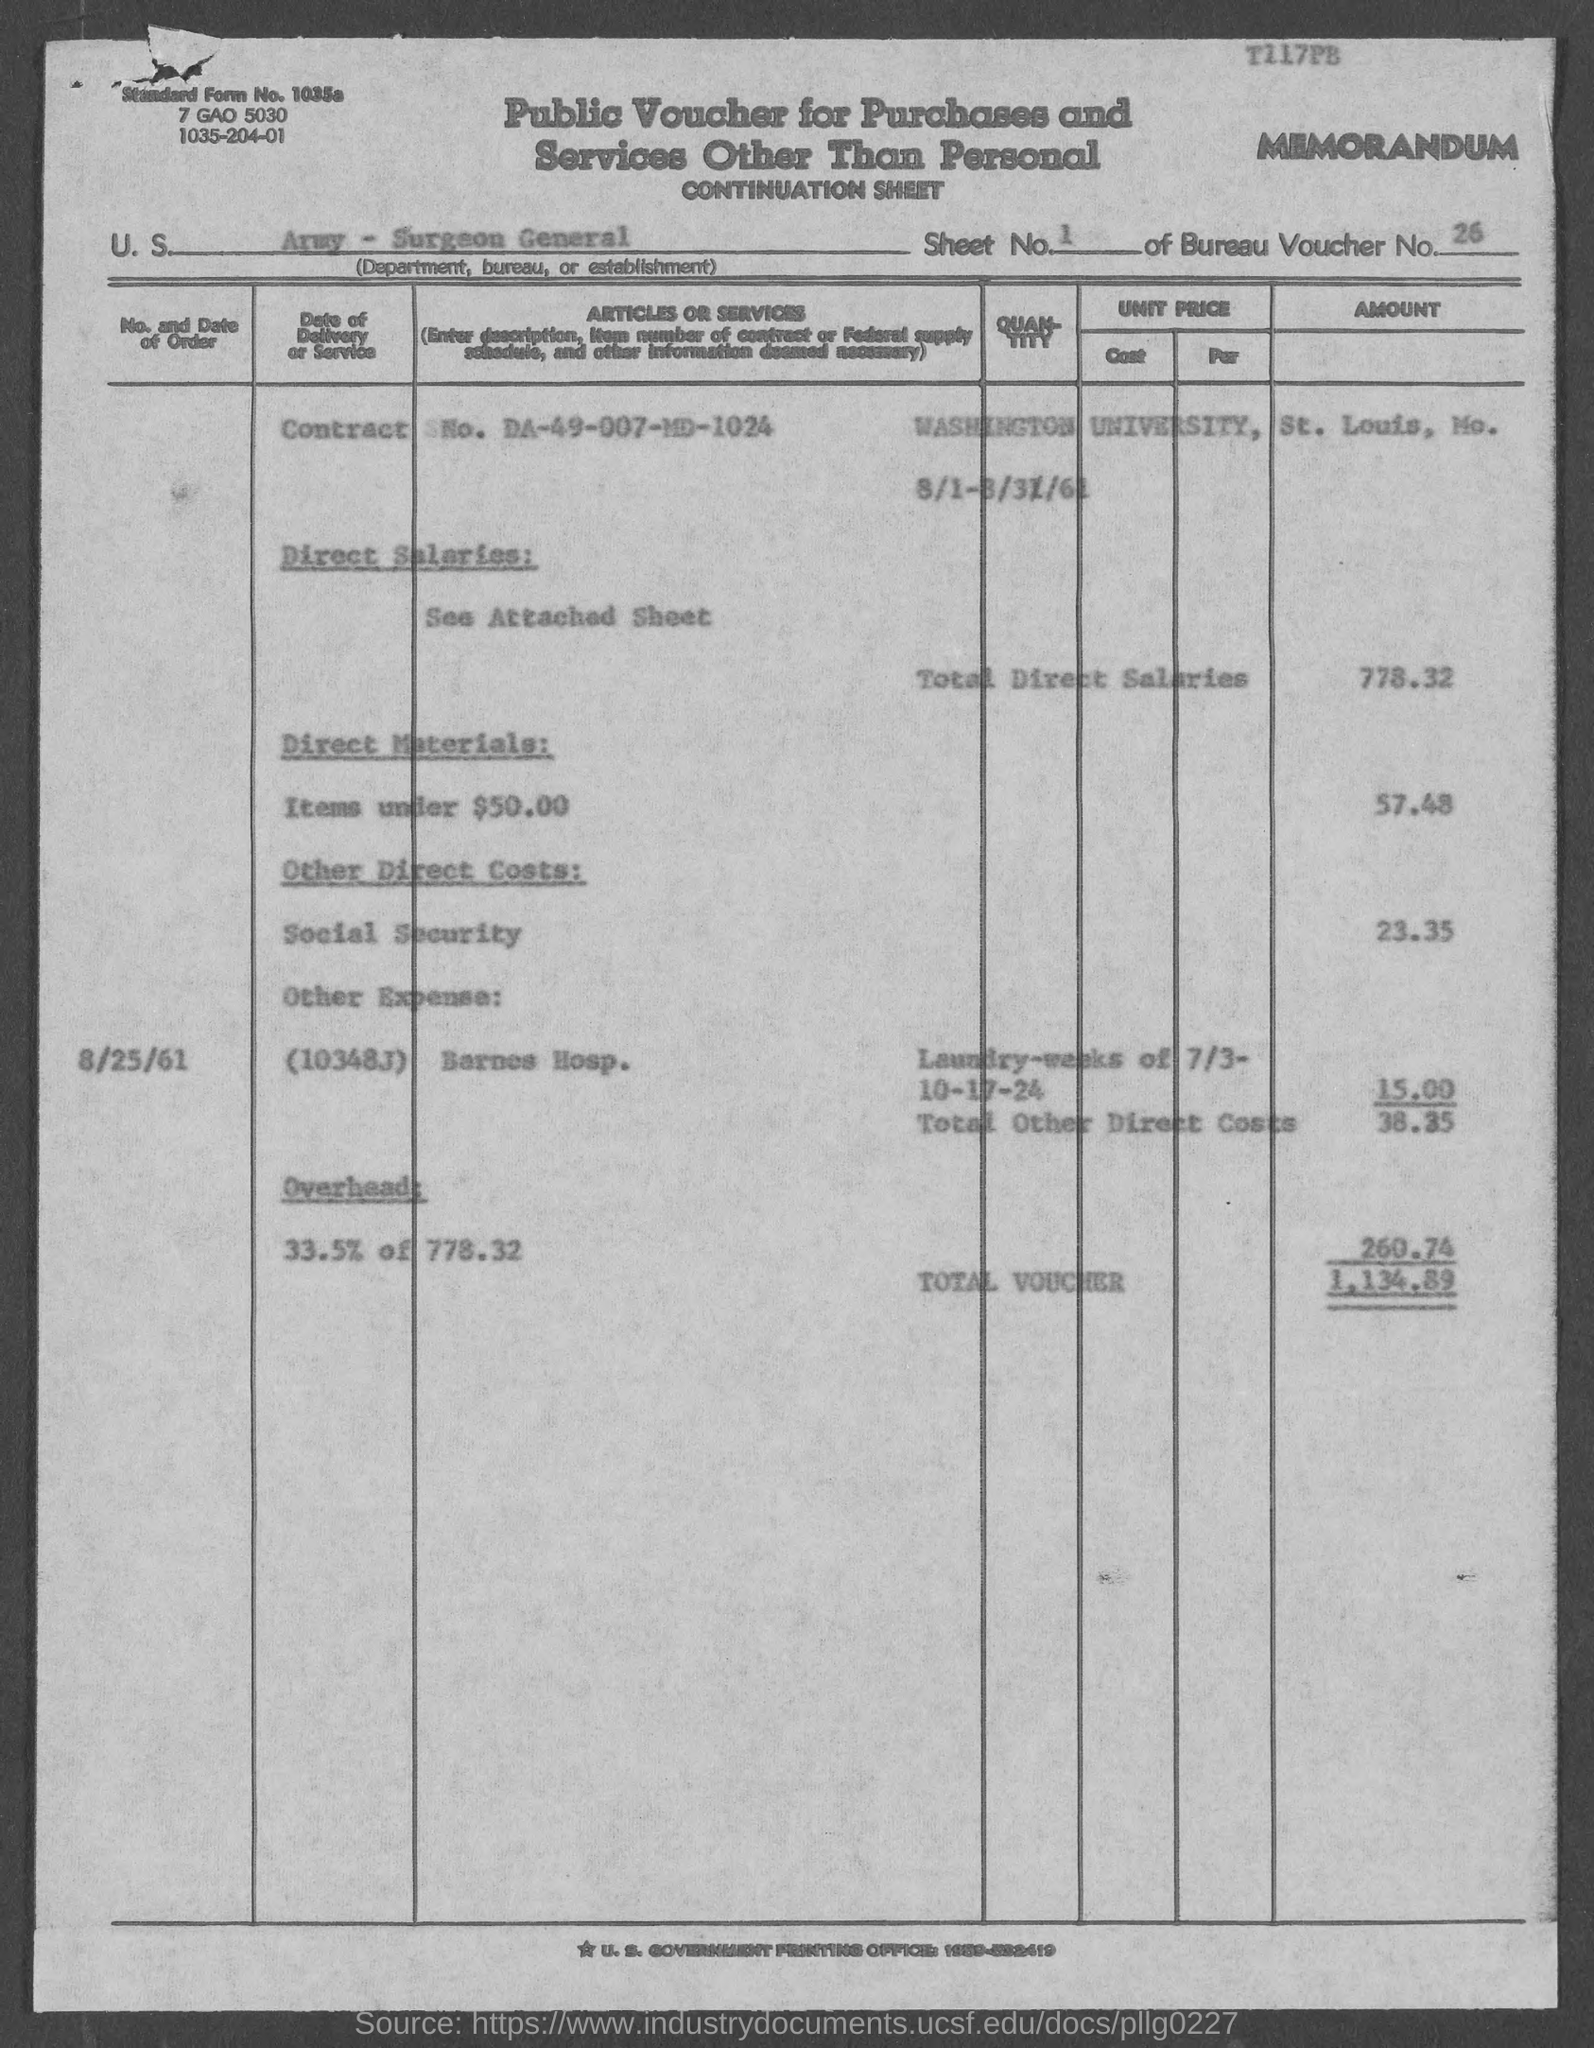Identify some key points in this picture. The cost of direct materials is $57.48. The Army Surgeon General has been entrusted with the responsibility of providing support in the form of medical services to US military personnel stationed at various locations. The total voucher amount is 1134.89. The bureau voucher number is 26. Under the subheading 'See Attached Sheet,' Direct Salaries is listed. 